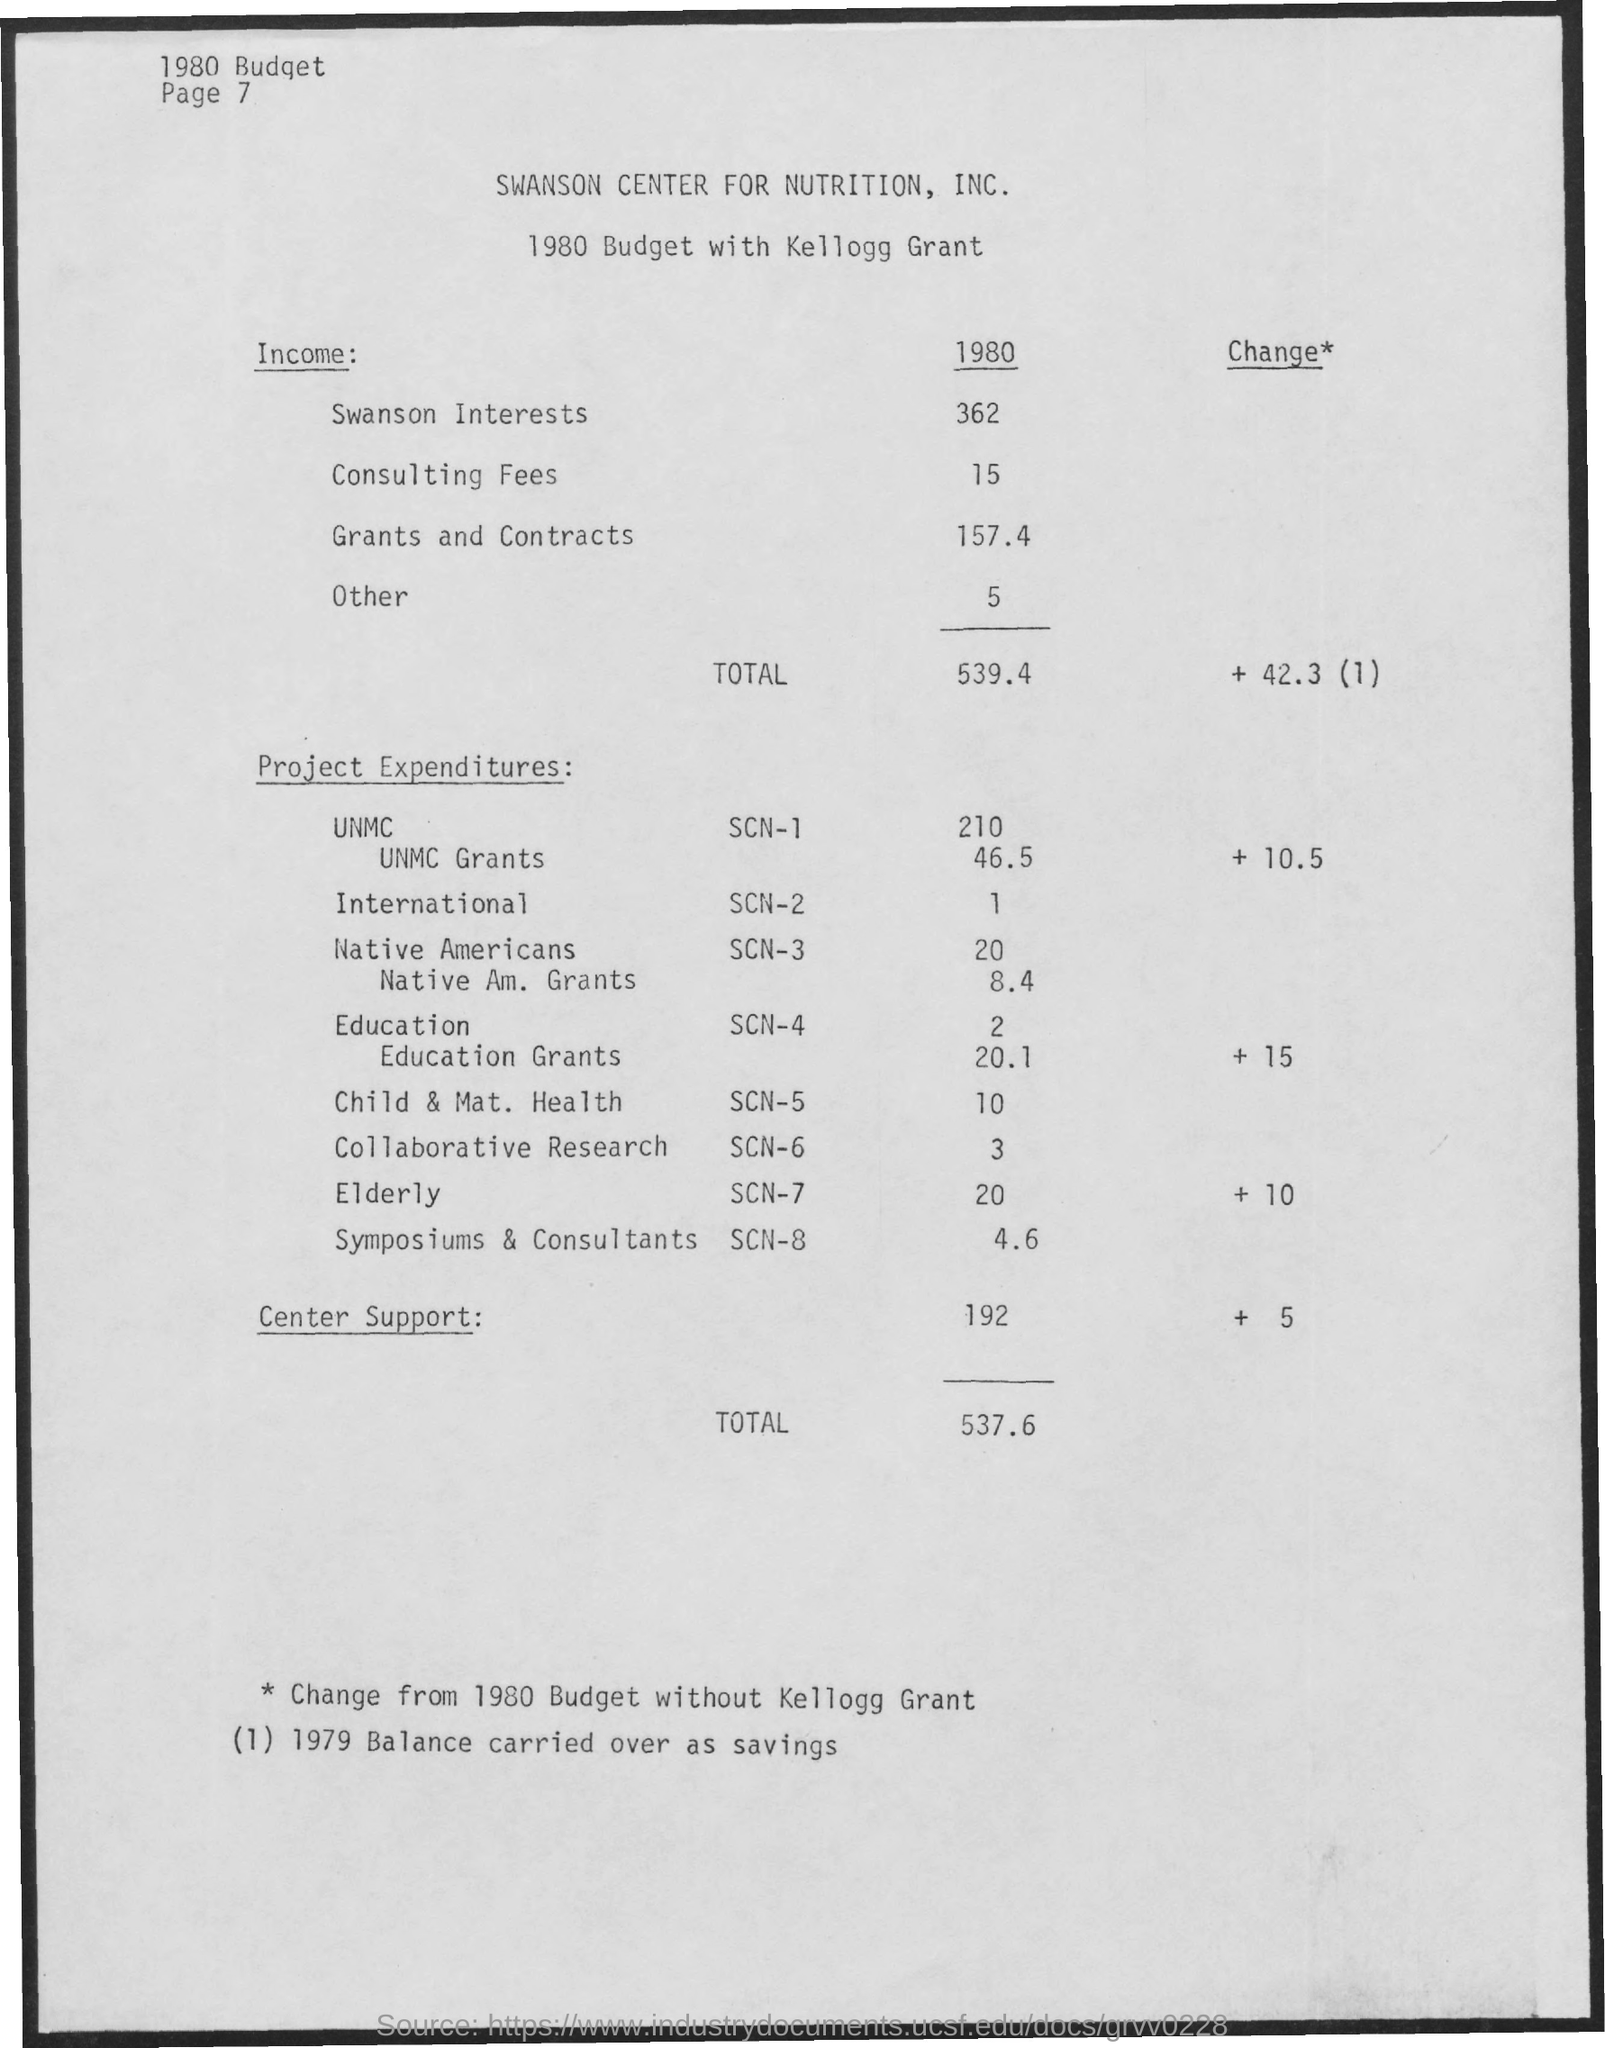Mention a couple of crucial points in this snapshot. The project expenditure for Education SCN-4 is $2. The project expenditure for Elderly SCN-7 is currently 20... In 1980, the income from grants and contracts was 157.4. The project expenditure for Native Americans SCN-3 is $20.. The total income is 539.4. 